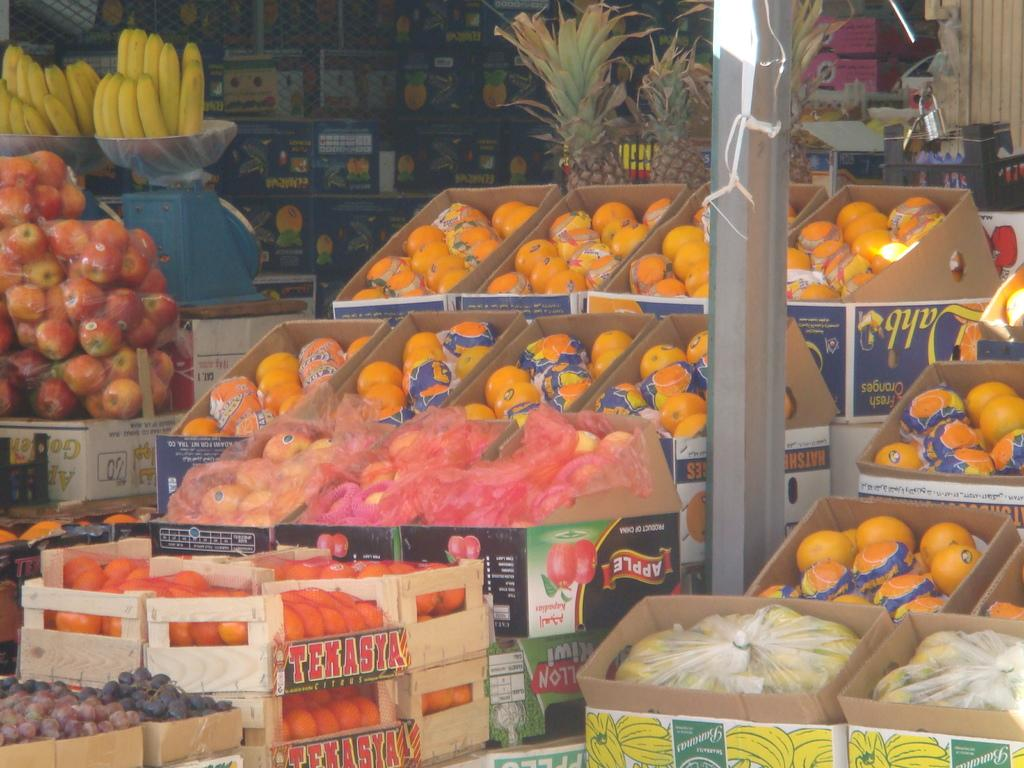What type of food can be seen in the image? There are fruits in the image. What is located in the middle of the image? There is a pole in the middle of the image. What type of locket is hanging from the pole in the image? There is no locket present in the image; it only features fruits and a pole. How are the fruits being measured in the image? The fruits are not being measured in the image; there is no measuring device or indication of measurement. 